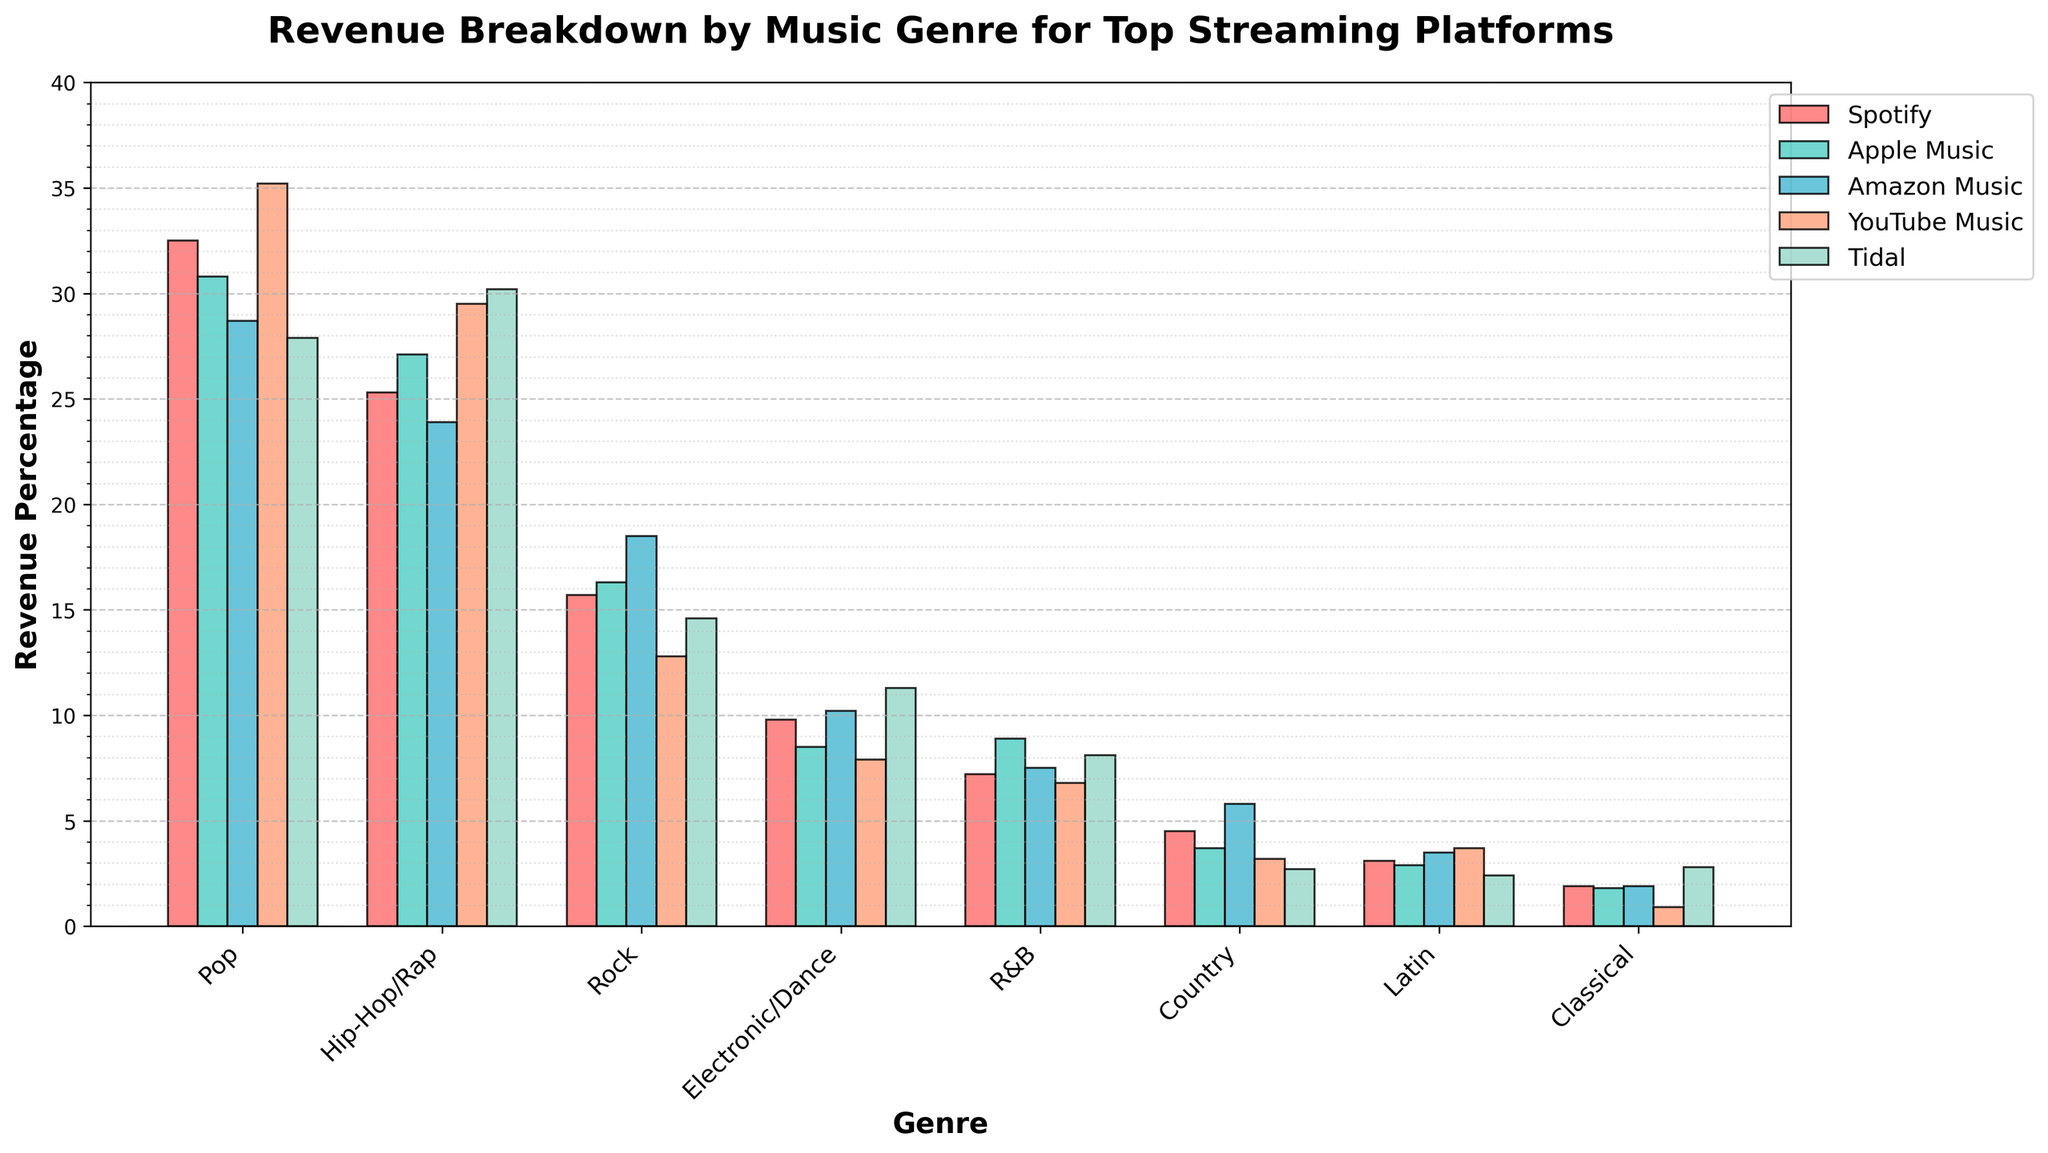What's the genre with the highest revenue on YouTube Music? Observe the bars representing YouTube Music (the yellow bars). The tallest bar for YouTube Music is for Pop music, indicating that Pop has the highest revenue on YouTube Music.
Answer: Pop Which platform has the highest revenue percentage for Electronic/Dance music? Look at the bars corresponding to Electronic/Dance music. The tallest bar among these represents Tidal, indicating Tidal has the highest revenue percentage for Electronic/Dance music.
Answer: Tidal Compare Rock and Hip-Hop/Rap revenues on Spotify. Which genre has more, and by how much? Observe the bars for Rock and Hip-Hop/Rap on Spotify. The bar for Hip-Hop/Rap is higher than Rock. Subtract the percentage of Rock (15.7) from Hip-Hop/Rap (25.3) to find the difference.
Answer: Hip-Hop/Rap, 9.6% What's the average revenue percentage for Pop across all platforms? Add the revenue percentages for Pop across all platforms (32.5, 30.8, 28.7, 35.2, 27.9) and divide by the number of platforms (5). (32.5 + 30.8 + 28.7 + 35.2 + 27.9) / 5 = 31.02
Answer: 31.02 Which genre consistently has the lowest revenue percentage across all platforms? Observe all the bars to determine the genre with the smallest bars consistently across platforms. Country music generally has the lowest bars.
Answer: Country For Apple Music, what is the difference in revenue percentage between the highest and lowest genres? Identify the highest and lowest Apple Music bars: Pop (30.8) and Classical (1.8). Subtract the lowest from the highest: 30.8 - 1.8 = 29.
Answer: 29 In which genre and platform combination do we see the smallest revenue percentage? Identify the smallest bar across all combinations. Classical music on YouTube Music has the smallest bar, recorded at 0.9.
Answer: Classical, YouTube Music Which two platforms have the closest revenue percentages for R&B? Compare the bars for R&B across all platforms. Spotify and Tidal have close figures with 7.2 and 8.1 respectively.
Answer: Spotify, Tidal What's the combined revenue percentage of Latin music on Amazon Music and YouTube Music? Add the revenue percentages for Latin music on these platforms: 3.5 (Amazon Music) + 3.7 (YouTube Music) = 7.2.
Answer: 7.2 How much more is the revenue percentage of Country music on Amazon Music compared to Tidal? Subtract the revenue percentage of Country on Tidal (2.7) from that on Amazon Music (5.8): 5.8 - 2.7 = 3.1.
Answer: 3.1 